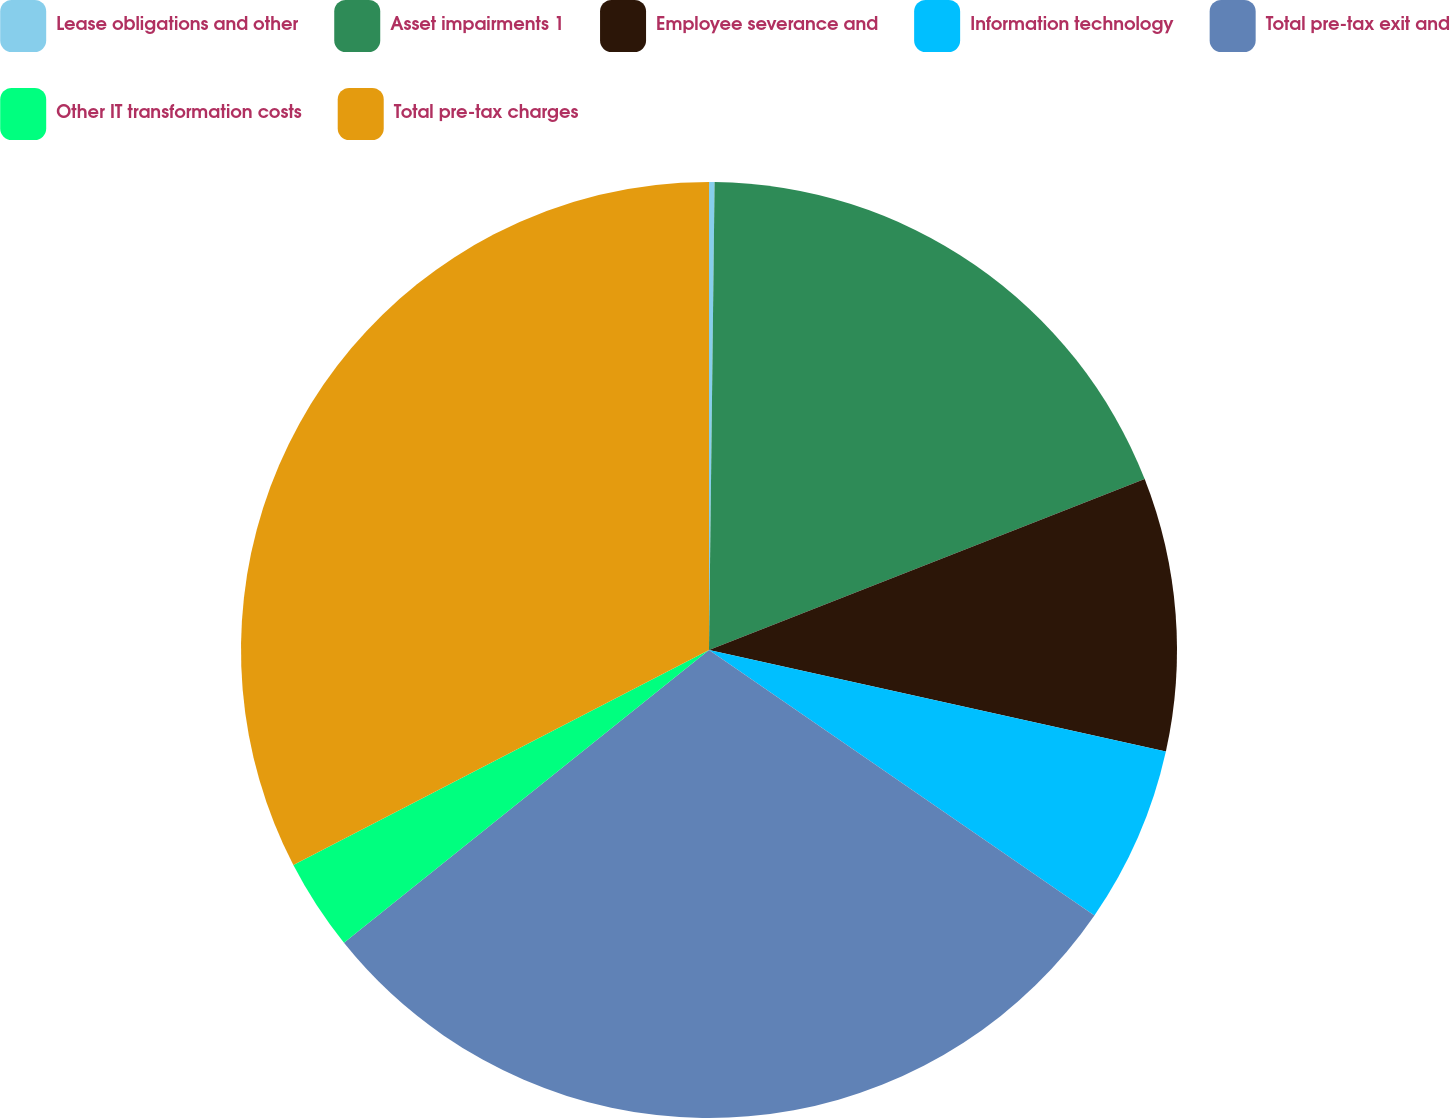Convert chart. <chart><loc_0><loc_0><loc_500><loc_500><pie_chart><fcel>Lease obligations and other<fcel>Asset impairments 1<fcel>Employee severance and<fcel>Information technology<fcel>Total pre-tax exit and<fcel>Other IT transformation costs<fcel>Total pre-tax charges<nl><fcel>0.19%<fcel>18.86%<fcel>9.43%<fcel>6.12%<fcel>29.64%<fcel>3.16%<fcel>32.6%<nl></chart> 